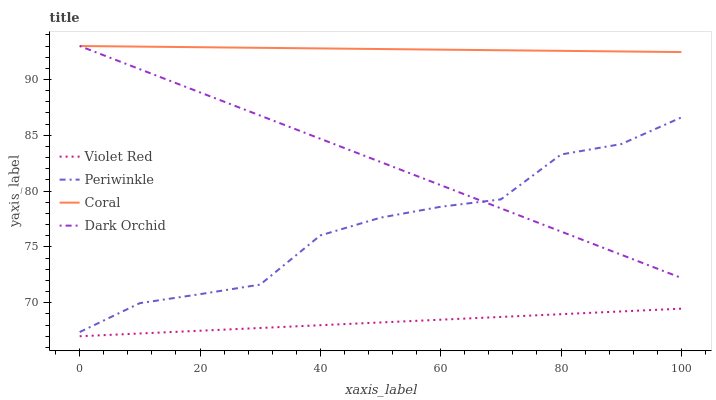Does Violet Red have the minimum area under the curve?
Answer yes or no. Yes. Does Coral have the maximum area under the curve?
Answer yes or no. Yes. Does Periwinkle have the minimum area under the curve?
Answer yes or no. No. Does Periwinkle have the maximum area under the curve?
Answer yes or no. No. Is Coral the smoothest?
Answer yes or no. Yes. Is Periwinkle the roughest?
Answer yes or no. Yes. Is Periwinkle the smoothest?
Answer yes or no. No. Is Coral the roughest?
Answer yes or no. No. Does Violet Red have the lowest value?
Answer yes or no. Yes. Does Periwinkle have the lowest value?
Answer yes or no. No. Does Dark Orchid have the highest value?
Answer yes or no. Yes. Does Periwinkle have the highest value?
Answer yes or no. No. Is Violet Red less than Dark Orchid?
Answer yes or no. Yes. Is Dark Orchid greater than Violet Red?
Answer yes or no. Yes. Does Periwinkle intersect Dark Orchid?
Answer yes or no. Yes. Is Periwinkle less than Dark Orchid?
Answer yes or no. No. Is Periwinkle greater than Dark Orchid?
Answer yes or no. No. Does Violet Red intersect Dark Orchid?
Answer yes or no. No. 